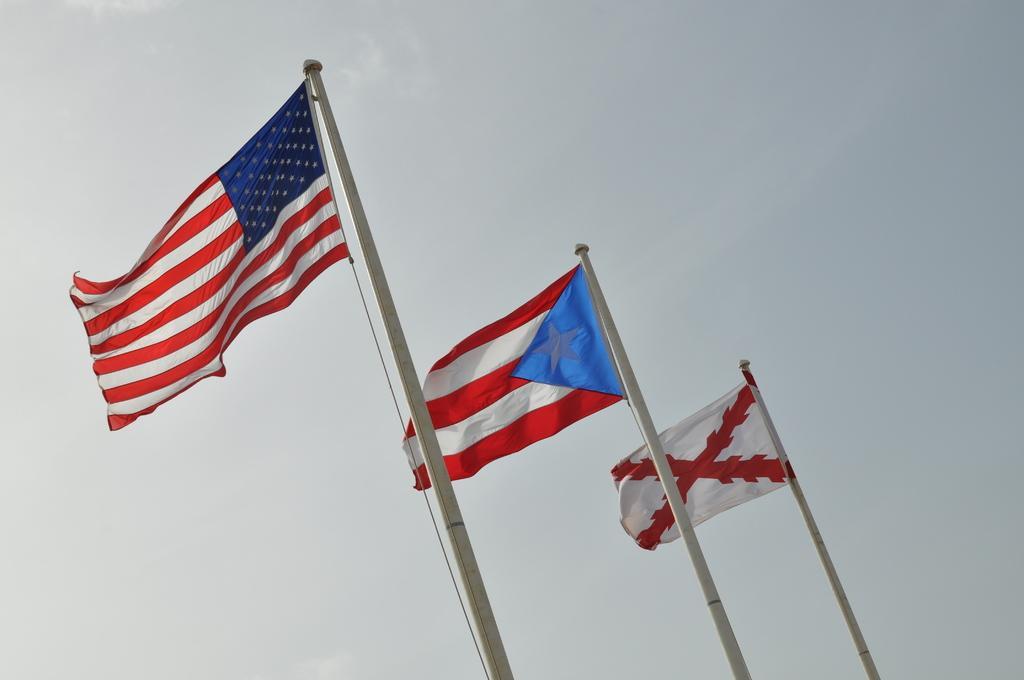Can you describe this image briefly? In the picture I can see three flags attached to poles. In the background I can see the sky. 